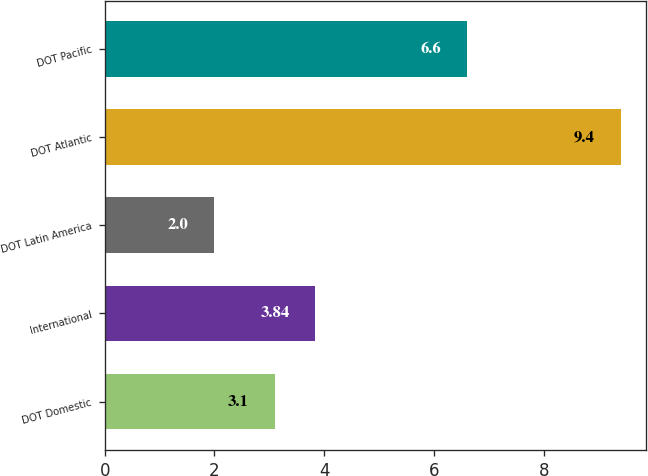Convert chart. <chart><loc_0><loc_0><loc_500><loc_500><bar_chart><fcel>DOT Domestic<fcel>International<fcel>DOT Latin America<fcel>DOT Atlantic<fcel>DOT Pacific<nl><fcel>3.1<fcel>3.84<fcel>2<fcel>9.4<fcel>6.6<nl></chart> 